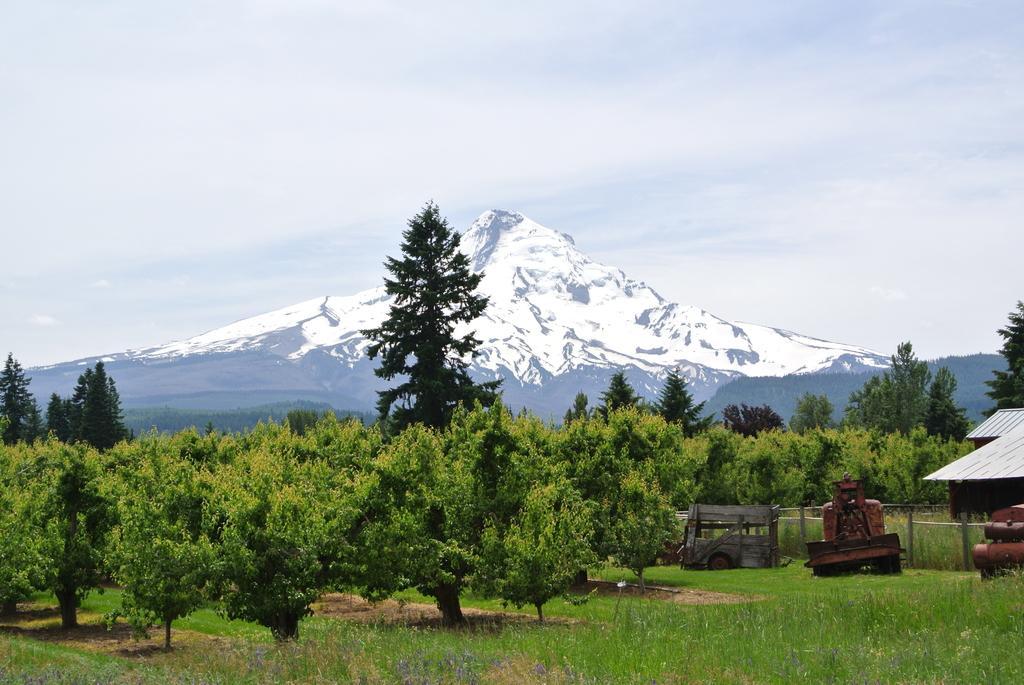Can you describe this image briefly? This image consists of many trees. At the bottom, there is green grass. On the right, we can see the vehicles. In the background, we can see the mountains covered with snow. At the top, there is sky. 